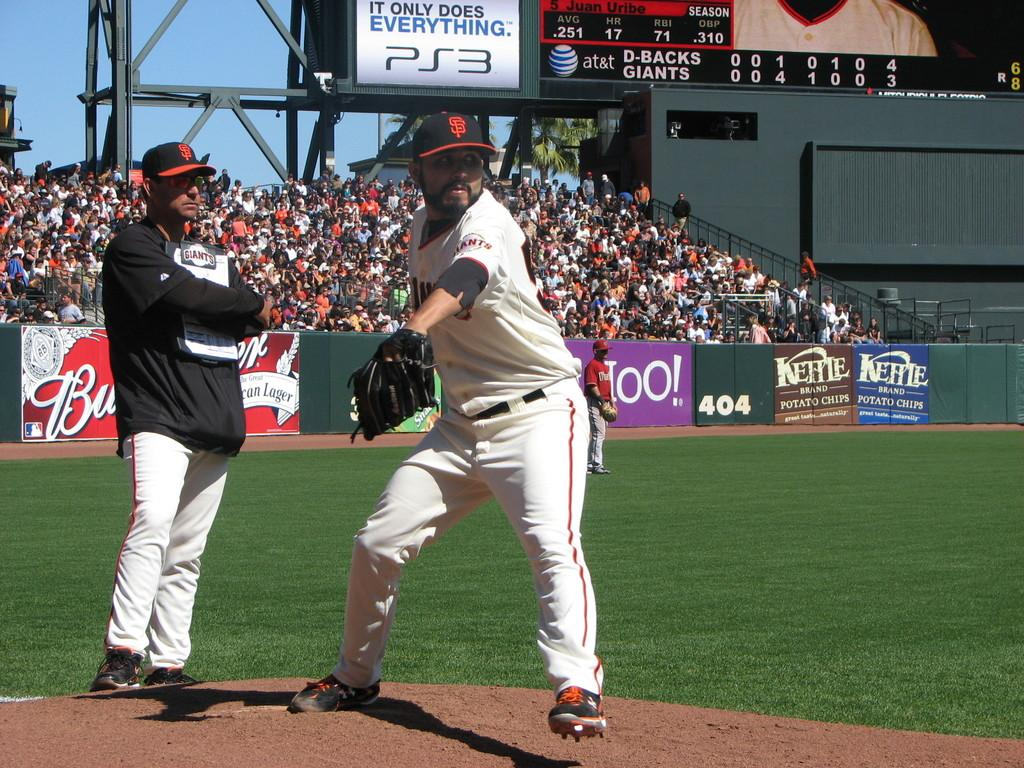<image>
Render a clear and concise summary of the photo. Some sports players in front of an advert for Kettle Chips. 